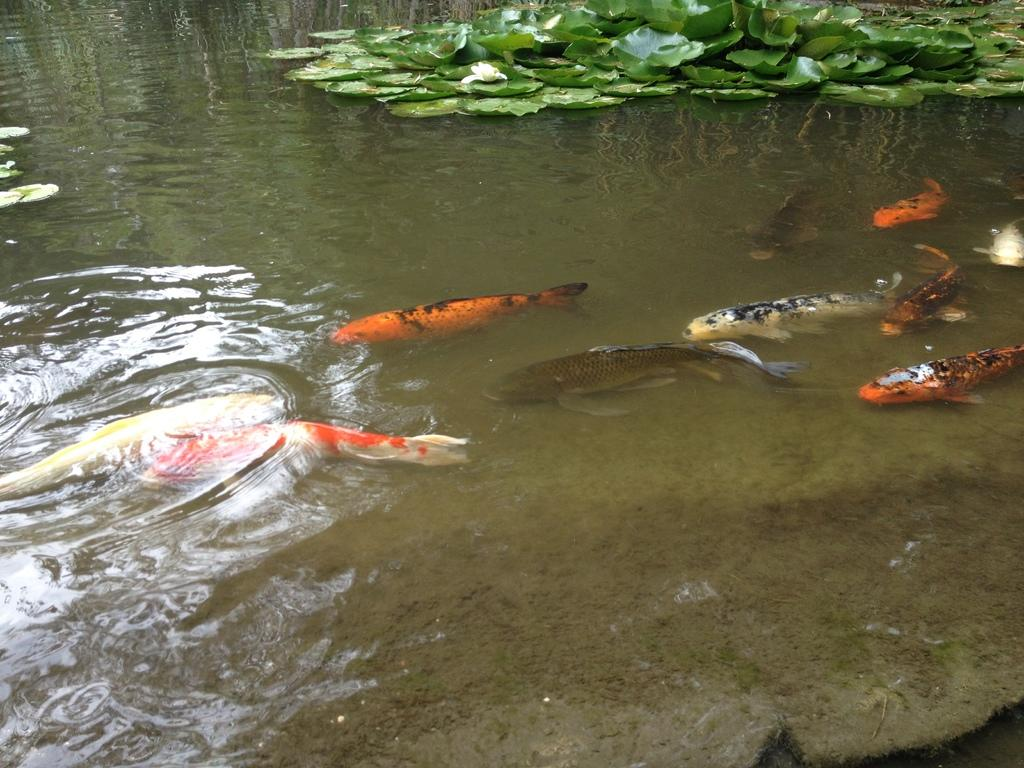What type of animals can be seen in the water in the image? There are fishes in the water in the image. What else can be seen floating on the water? There are plants floating on the water in the image. What type of key can be seen unlocking the door in the image? There is no door or key present in the image; it features fishes and plants in the water. 